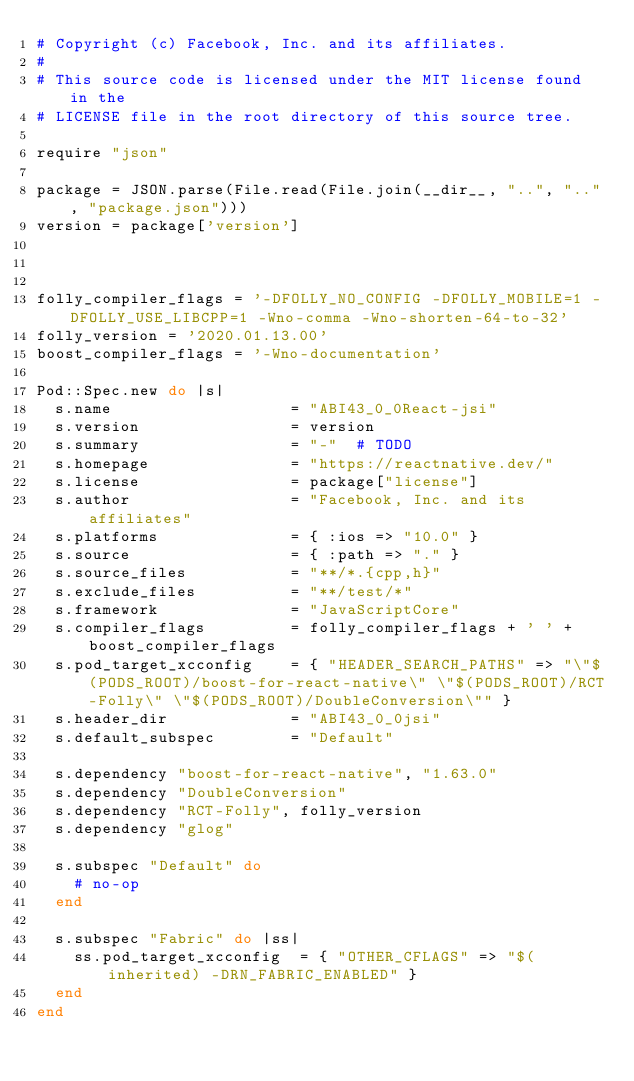Convert code to text. <code><loc_0><loc_0><loc_500><loc_500><_Ruby_># Copyright (c) Facebook, Inc. and its affiliates.
#
# This source code is licensed under the MIT license found in the
# LICENSE file in the root directory of this source tree.

require "json"

package = JSON.parse(File.read(File.join(__dir__, "..", "..", "package.json")))
version = package['version']



folly_compiler_flags = '-DFOLLY_NO_CONFIG -DFOLLY_MOBILE=1 -DFOLLY_USE_LIBCPP=1 -Wno-comma -Wno-shorten-64-to-32'
folly_version = '2020.01.13.00'
boost_compiler_flags = '-Wno-documentation'

Pod::Spec.new do |s|
  s.name                   = "ABI43_0_0React-jsi"
  s.version                = version
  s.summary                = "-"  # TODO
  s.homepage               = "https://reactnative.dev/"
  s.license                = package["license"]
  s.author                 = "Facebook, Inc. and its affiliates"
  s.platforms              = { :ios => "10.0" }
  s.source                 = { :path => "." }
  s.source_files           = "**/*.{cpp,h}"
  s.exclude_files          = "**/test/*"
  s.framework              = "JavaScriptCore"
  s.compiler_flags         = folly_compiler_flags + ' ' + boost_compiler_flags
  s.pod_target_xcconfig    = { "HEADER_SEARCH_PATHS" => "\"$(PODS_ROOT)/boost-for-react-native\" \"$(PODS_ROOT)/RCT-Folly\" \"$(PODS_ROOT)/DoubleConversion\"" }
  s.header_dir             = "ABI43_0_0jsi"
  s.default_subspec        = "Default"

  s.dependency "boost-for-react-native", "1.63.0"
  s.dependency "DoubleConversion"
  s.dependency "RCT-Folly", folly_version
  s.dependency "glog"

  s.subspec "Default" do
    # no-op
  end

  s.subspec "Fabric" do |ss|
    ss.pod_target_xcconfig  = { "OTHER_CFLAGS" => "$(inherited) -DRN_FABRIC_ENABLED" }
  end
end
</code> 